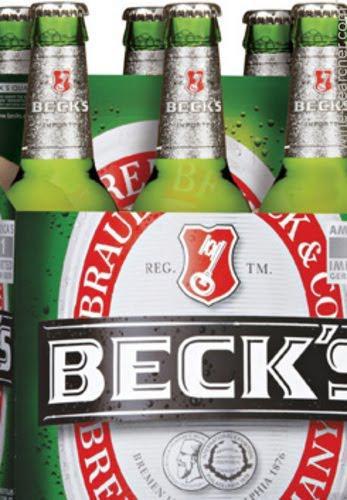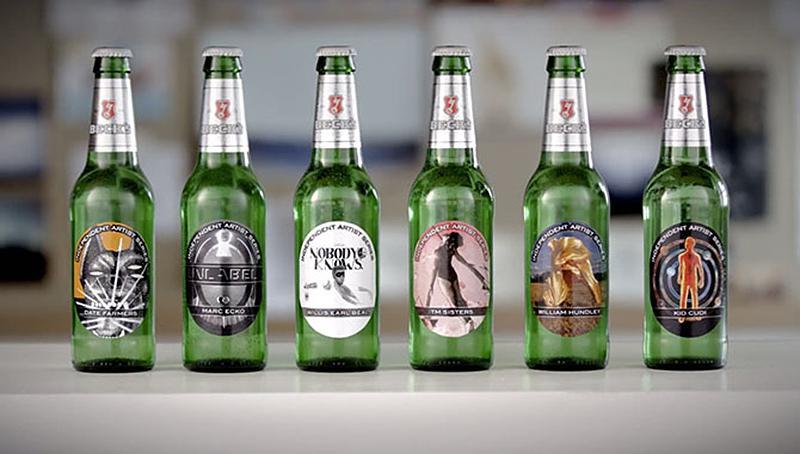The first image is the image on the left, the second image is the image on the right. Analyze the images presented: Is the assertion "Some of the beer is served in a glass, and some is still in bottles." valid? Answer yes or no. No. The first image is the image on the left, the second image is the image on the right. For the images displayed, is the sentence "Four or fewer beer bottles are visible." factually correct? Answer yes or no. No. 